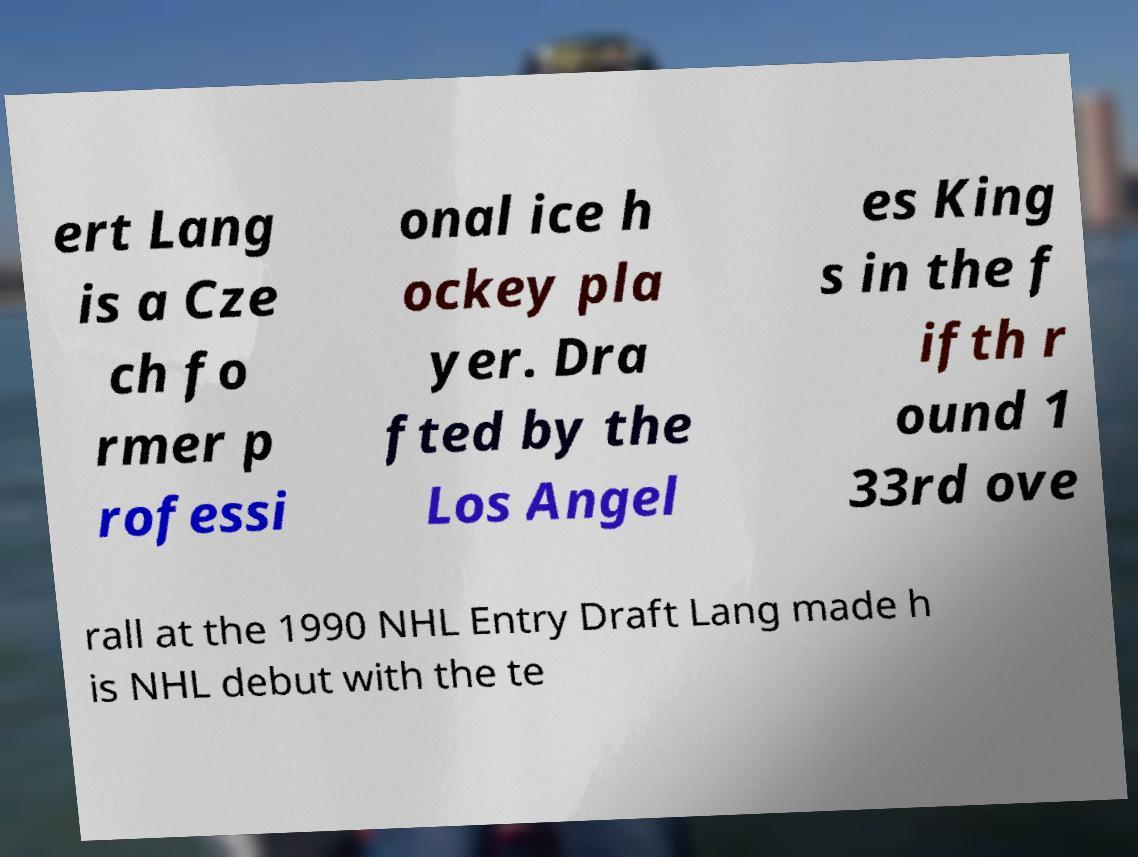For documentation purposes, I need the text within this image transcribed. Could you provide that? ert Lang is a Cze ch fo rmer p rofessi onal ice h ockey pla yer. Dra fted by the Los Angel es King s in the f ifth r ound 1 33rd ove rall at the 1990 NHL Entry Draft Lang made h is NHL debut with the te 